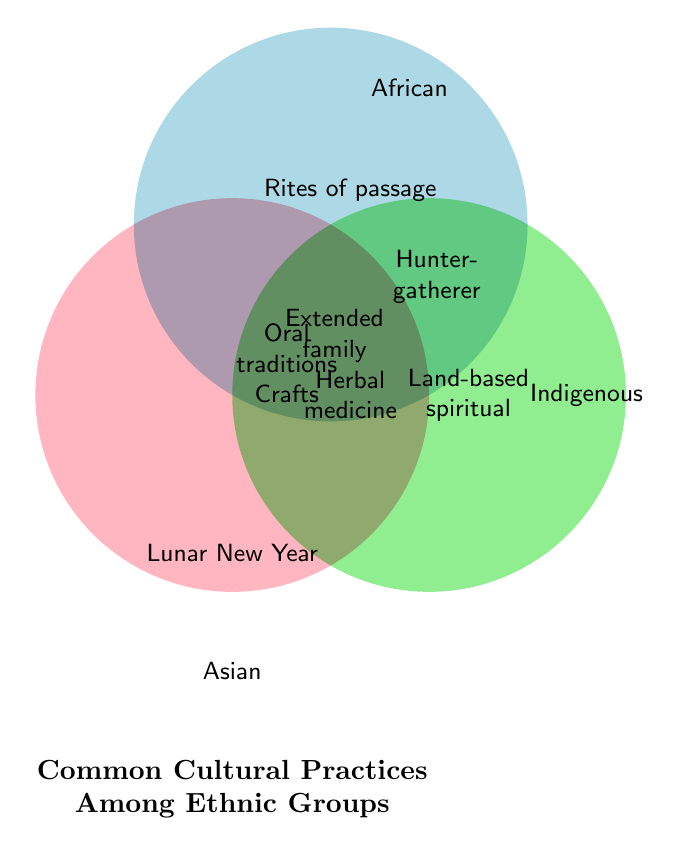What's the title of the Venn Diagram? The title is stated at the bottom of the Venn Diagram as "Common Cultural Practices Among Ethnic Groups."
Answer: Common Cultural Practices Among Ethnic Groups Which group practices Lunar New Year celebrations? Lunar New Year celebrations are listed within the circle for the Asian group.
Answer: Asian Name a practice that is common to all three groups. Practices that are in the overlap of all three circles represent common practices. "Oral storytelling traditions" and "Traditional crafts and artisanship" are listed in this area.
Answer: Oral storytelling traditions How many practices are unique to the African group? By examining the African circle without any overlaps, we see "Rites of passage ceremonies" and "Drumming and dance rituals" are unique to the African group.
Answer: 2 Which two groups share the practice of "Extended family structures"? The practice "Extended family structures" is in the overlapping area between the Asian and African circles. This indicates that it is shared by these two groups.
Answer: Asian and African What practices are shared between the Asian and Indigenous groups? The overlapping area between the Asian and Indigenous circles shows "Traditional herbal medicine."
Answer: Traditional herbal medicine Which practice is located in all three group sections? In the overlapping area shared by all three groups, "Oral storytelling traditions" and "Traditional crafts and artisanship" are listed.
Answer: Traditional crafts and artisanship How many practices are shared between African and Indigenous groups? The overlap between the African and Indigenous circles contains "Hunter-gatherer techniques."
Answer: 1 Which groups have more than one shared practice? The pairs with more than one shared practice include Asian and African (2 practices), and all three groups have 2 shared practices.
Answer: Asian, African, and All three groups 